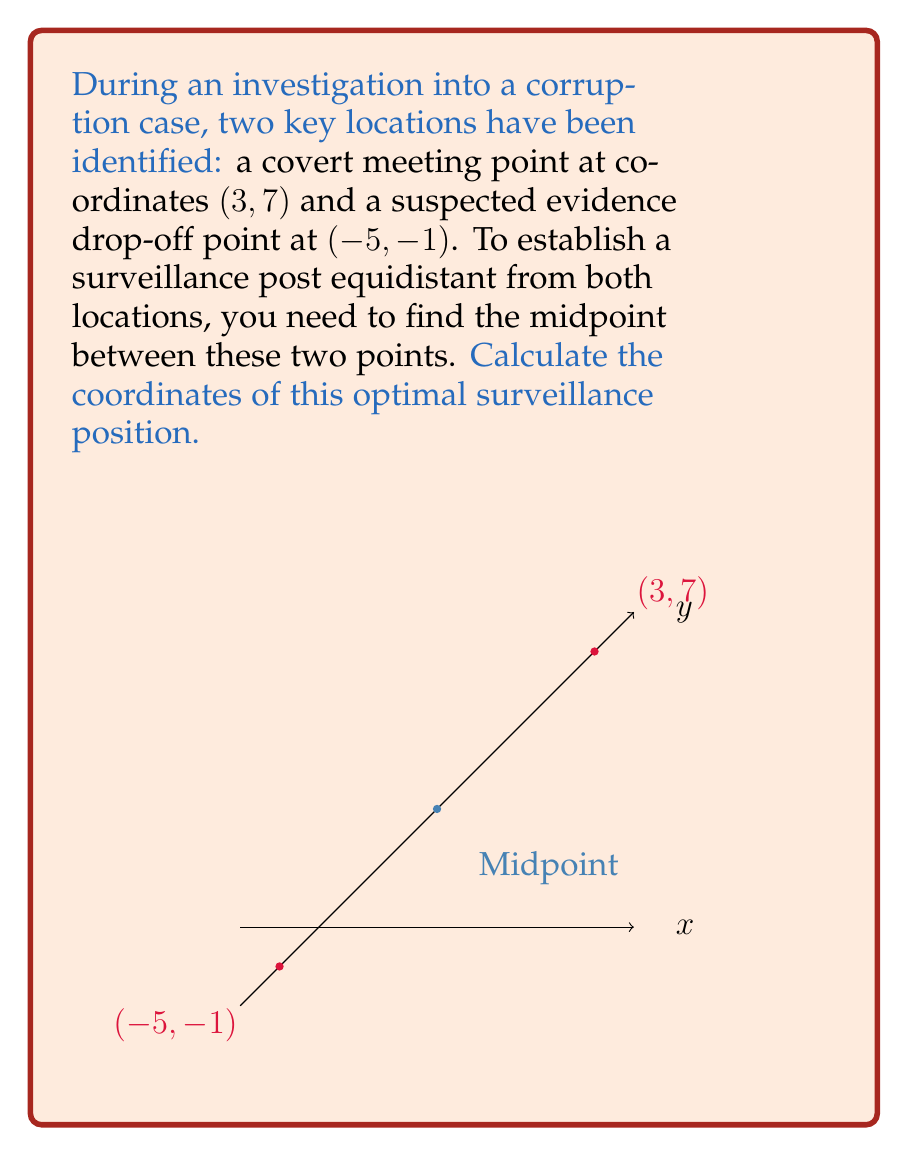Can you solve this math problem? To find the midpoint between two points $(x_1, y_1)$ and $(x_2, y_2)$, we use the midpoint formula:

$$\left(\frac{x_1 + x_2}{2}, \frac{y_1 + y_2}{2}\right)$$

Given:
- Point 1 (covert meeting point): $(x_1, y_1) = (3, 7)$
- Point 2 (evidence drop-off point): $(x_2, y_2) = (-5, -1)$

Step 1: Calculate the x-coordinate of the midpoint
$$x_{midpoint} = \frac{x_1 + x_2}{2} = \frac{3 + (-5)}{2} = \frac{-2}{2} = -1$$

Step 2: Calculate the y-coordinate of the midpoint
$$y_{midpoint} = \frac{y_1 + y_2}{2} = \frac{7 + (-1)}{2} = \frac{6}{2} = 3$$

Therefore, the coordinates of the optimal surveillance position (midpoint) are $(-1, 3)$.
Answer: $(-1, 3)$ 